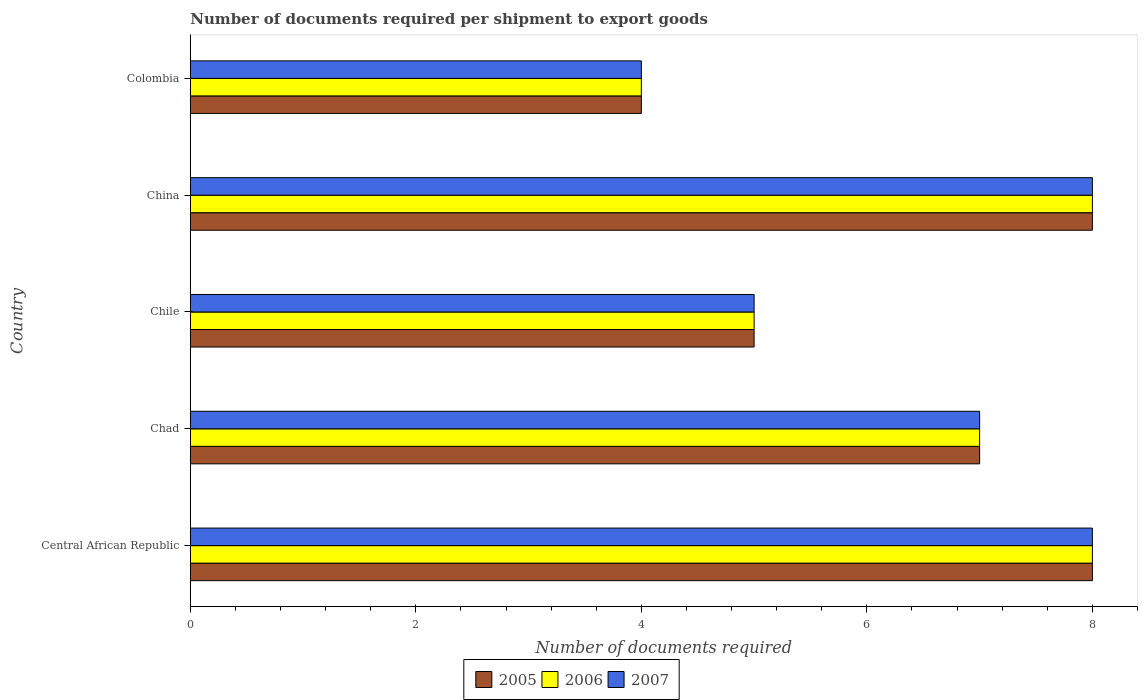How many different coloured bars are there?
Provide a short and direct response. 3. Are the number of bars per tick equal to the number of legend labels?
Ensure brevity in your answer.  Yes. Are the number of bars on each tick of the Y-axis equal?
Provide a short and direct response. Yes. How many bars are there on the 2nd tick from the top?
Your answer should be very brief. 3. What is the label of the 4th group of bars from the top?
Provide a short and direct response. Chad. In how many cases, is the number of bars for a given country not equal to the number of legend labels?
Provide a succinct answer. 0. What is the number of documents required per shipment to export goods in 2006 in Chile?
Offer a very short reply. 5. In which country was the number of documents required per shipment to export goods in 2005 maximum?
Offer a very short reply. Central African Republic. In which country was the number of documents required per shipment to export goods in 2007 minimum?
Provide a short and direct response. Colombia. What is the difference between the number of documents required per shipment to export goods in 2006 in Chad and that in China?
Your answer should be very brief. -1. In how many countries, is the number of documents required per shipment to export goods in 2006 greater than 4.8 ?
Ensure brevity in your answer.  4. What is the ratio of the number of documents required per shipment to export goods in 2005 in Chad to that in Chile?
Offer a terse response. 1.4. Is the difference between the number of documents required per shipment to export goods in 2007 in Chile and China greater than the difference between the number of documents required per shipment to export goods in 2006 in Chile and China?
Offer a terse response. No. What is the difference between the highest and the lowest number of documents required per shipment to export goods in 2007?
Keep it short and to the point. 4. Is the sum of the number of documents required per shipment to export goods in 2007 in Chile and Colombia greater than the maximum number of documents required per shipment to export goods in 2005 across all countries?
Make the answer very short. Yes. How many bars are there?
Make the answer very short. 15. How many countries are there in the graph?
Provide a succinct answer. 5. What is the difference between two consecutive major ticks on the X-axis?
Give a very brief answer. 2. Does the graph contain any zero values?
Your answer should be very brief. No. Does the graph contain grids?
Offer a terse response. No. Where does the legend appear in the graph?
Provide a short and direct response. Bottom center. How many legend labels are there?
Your answer should be compact. 3. How are the legend labels stacked?
Keep it short and to the point. Horizontal. What is the title of the graph?
Ensure brevity in your answer.  Number of documents required per shipment to export goods. Does "1965" appear as one of the legend labels in the graph?
Your answer should be very brief. No. What is the label or title of the X-axis?
Offer a very short reply. Number of documents required. What is the Number of documents required of 2005 in Central African Republic?
Give a very brief answer. 8. What is the Number of documents required of 2006 in Central African Republic?
Your response must be concise. 8. What is the Number of documents required of 2007 in Central African Republic?
Your answer should be compact. 8. What is the Number of documents required of 2005 in Chad?
Provide a succinct answer. 7. What is the Number of documents required of 2006 in Chad?
Give a very brief answer. 7. What is the Number of documents required of 2005 in Chile?
Your response must be concise. 5. What is the Number of documents required in 2006 in China?
Provide a short and direct response. 8. What is the Number of documents required in 2006 in Colombia?
Give a very brief answer. 4. Across all countries, what is the maximum Number of documents required of 2005?
Provide a succinct answer. 8. Across all countries, what is the maximum Number of documents required in 2006?
Ensure brevity in your answer.  8. Across all countries, what is the maximum Number of documents required of 2007?
Offer a terse response. 8. Across all countries, what is the minimum Number of documents required in 2005?
Make the answer very short. 4. Across all countries, what is the minimum Number of documents required in 2006?
Offer a very short reply. 4. Across all countries, what is the minimum Number of documents required in 2007?
Offer a terse response. 4. What is the total Number of documents required of 2006 in the graph?
Ensure brevity in your answer.  32. What is the difference between the Number of documents required in 2007 in Central African Republic and that in Chad?
Your answer should be very brief. 1. What is the difference between the Number of documents required of 2006 in Central African Republic and that in Chile?
Your answer should be compact. 3. What is the difference between the Number of documents required of 2007 in Central African Republic and that in China?
Offer a terse response. 0. What is the difference between the Number of documents required of 2007 in Central African Republic and that in Colombia?
Make the answer very short. 4. What is the difference between the Number of documents required in 2005 in Chad and that in Colombia?
Provide a succinct answer. 3. What is the difference between the Number of documents required of 2006 in Chile and that in China?
Ensure brevity in your answer.  -3. What is the difference between the Number of documents required of 2006 in Chile and that in Colombia?
Offer a very short reply. 1. What is the difference between the Number of documents required in 2005 in China and that in Colombia?
Provide a short and direct response. 4. What is the difference between the Number of documents required in 2005 in Central African Republic and the Number of documents required in 2006 in Chad?
Your answer should be very brief. 1. What is the difference between the Number of documents required of 2005 in Central African Republic and the Number of documents required of 2007 in Chad?
Make the answer very short. 1. What is the difference between the Number of documents required in 2006 in Central African Republic and the Number of documents required in 2007 in Chad?
Your answer should be compact. 1. What is the difference between the Number of documents required of 2005 in Central African Republic and the Number of documents required of 2007 in Chile?
Give a very brief answer. 3. What is the difference between the Number of documents required of 2005 in Central African Republic and the Number of documents required of 2006 in China?
Offer a very short reply. 0. What is the difference between the Number of documents required in 2006 in Central African Republic and the Number of documents required in 2007 in Colombia?
Provide a short and direct response. 4. What is the difference between the Number of documents required of 2005 in Chad and the Number of documents required of 2007 in Chile?
Your answer should be very brief. 2. What is the difference between the Number of documents required of 2005 in Chad and the Number of documents required of 2006 in China?
Ensure brevity in your answer.  -1. What is the difference between the Number of documents required in 2005 in Chad and the Number of documents required in 2006 in Colombia?
Your response must be concise. 3. What is the difference between the Number of documents required in 2005 in Chad and the Number of documents required in 2007 in Colombia?
Offer a very short reply. 3. What is the difference between the Number of documents required in 2006 in Chad and the Number of documents required in 2007 in Colombia?
Your response must be concise. 3. What is the difference between the Number of documents required of 2005 in Chile and the Number of documents required of 2006 in China?
Your response must be concise. -3. What is the difference between the Number of documents required in 2005 in Chile and the Number of documents required in 2006 in Colombia?
Make the answer very short. 1. What is the difference between the Number of documents required in 2005 in Chile and the Number of documents required in 2007 in Colombia?
Offer a terse response. 1. What is the difference between the Number of documents required of 2005 in China and the Number of documents required of 2006 in Colombia?
Your answer should be very brief. 4. What is the difference between the Number of documents required of 2005 in China and the Number of documents required of 2007 in Colombia?
Offer a very short reply. 4. What is the difference between the Number of documents required in 2006 in China and the Number of documents required in 2007 in Colombia?
Keep it short and to the point. 4. What is the difference between the Number of documents required of 2005 and Number of documents required of 2006 in Central African Republic?
Give a very brief answer. 0. What is the difference between the Number of documents required in 2006 and Number of documents required in 2007 in Central African Republic?
Give a very brief answer. 0. What is the difference between the Number of documents required in 2005 and Number of documents required in 2007 in Chad?
Ensure brevity in your answer.  0. What is the difference between the Number of documents required of 2005 and Number of documents required of 2006 in Chile?
Provide a succinct answer. 0. What is the difference between the Number of documents required in 2005 and Number of documents required in 2007 in Chile?
Make the answer very short. 0. What is the difference between the Number of documents required in 2006 and Number of documents required in 2007 in Colombia?
Your answer should be compact. 0. What is the ratio of the Number of documents required of 2007 in Central African Republic to that in Chad?
Your answer should be compact. 1.14. What is the ratio of the Number of documents required of 2006 in Central African Republic to that in Chile?
Give a very brief answer. 1.6. What is the ratio of the Number of documents required of 2005 in Central African Republic to that in China?
Give a very brief answer. 1. What is the ratio of the Number of documents required of 2006 in Central African Republic to that in China?
Offer a terse response. 1. What is the ratio of the Number of documents required in 2006 in Chad to that in Chile?
Offer a very short reply. 1.4. What is the ratio of the Number of documents required in 2006 in Chad to that in China?
Offer a very short reply. 0.88. What is the ratio of the Number of documents required in 2006 in Chad to that in Colombia?
Provide a short and direct response. 1.75. What is the ratio of the Number of documents required of 2007 in Chad to that in Colombia?
Your answer should be very brief. 1.75. What is the ratio of the Number of documents required of 2005 in Chile to that in China?
Give a very brief answer. 0.62. What is the ratio of the Number of documents required of 2007 in Chile to that in China?
Offer a terse response. 0.62. What is the ratio of the Number of documents required of 2007 in Chile to that in Colombia?
Keep it short and to the point. 1.25. What is the ratio of the Number of documents required in 2005 in China to that in Colombia?
Provide a short and direct response. 2. What is the ratio of the Number of documents required of 2006 in China to that in Colombia?
Your response must be concise. 2. What is the ratio of the Number of documents required in 2007 in China to that in Colombia?
Offer a terse response. 2. What is the difference between the highest and the second highest Number of documents required in 2006?
Your answer should be compact. 0. What is the difference between the highest and the second highest Number of documents required of 2007?
Ensure brevity in your answer.  0. What is the difference between the highest and the lowest Number of documents required in 2006?
Provide a short and direct response. 4. 